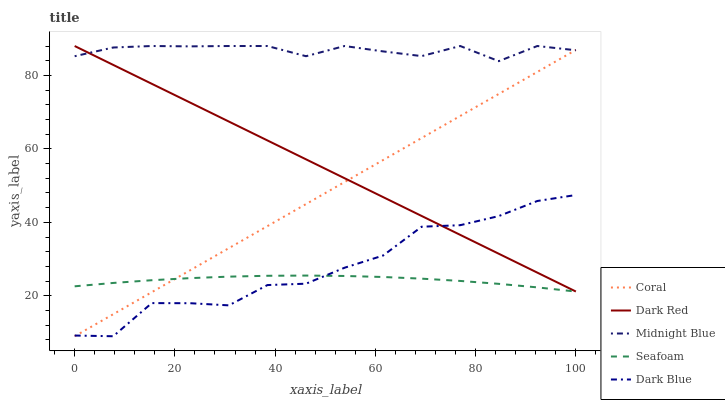Does Seafoam have the minimum area under the curve?
Answer yes or no. Yes. Does Midnight Blue have the maximum area under the curve?
Answer yes or no. Yes. Does Coral have the minimum area under the curve?
Answer yes or no. No. Does Coral have the maximum area under the curve?
Answer yes or no. No. Is Dark Red the smoothest?
Answer yes or no. Yes. Is Dark Blue the roughest?
Answer yes or no. Yes. Is Coral the smoothest?
Answer yes or no. No. Is Coral the roughest?
Answer yes or no. No. Does Coral have the lowest value?
Answer yes or no. Yes. Does Midnight Blue have the lowest value?
Answer yes or no. No. Does Midnight Blue have the highest value?
Answer yes or no. Yes. Does Coral have the highest value?
Answer yes or no. No. Is Dark Blue less than Midnight Blue?
Answer yes or no. Yes. Is Midnight Blue greater than Seafoam?
Answer yes or no. Yes. Does Coral intersect Dark Red?
Answer yes or no. Yes. Is Coral less than Dark Red?
Answer yes or no. No. Is Coral greater than Dark Red?
Answer yes or no. No. Does Dark Blue intersect Midnight Blue?
Answer yes or no. No. 